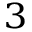<formula> <loc_0><loc_0><loc_500><loc_500>^ { 3 }</formula> 